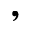<formula> <loc_0><loc_0><loc_500><loc_500>,</formula> 